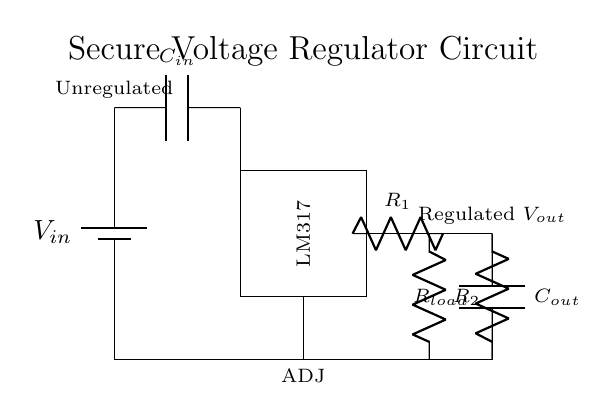What type of voltage regulator is shown? The circuit depicts a linear voltage regulator, specifically the LM317, which is designed to provide a stable output voltage.
Answer: LM317 What is the function of capacitor C_in? Capacitor C_in is used to filter and smooth out the input voltage to the regulator, reducing spikes and noise for stable operation.
Answer: Filter What is the output voltage labeled as in this circuit? The output voltage is labeled as V_out, indicating the regulated voltage supplied to the load connected at the output of the circuit.
Answer: V_out What components comprise the voltage divider in the circuit? The voltage divider consists of two resistors, R_1 and R_2, which set the output voltage based on their resistance values.
Answer: R_1, R_2 Why is there a need for the adjustment pin in the circuit? The ADJ pin allows for adjusting the output voltage level by connecting it to a voltage divider network, thus providing flexibility in output settings.
Answer: Flexibility What happens to the output when R_load increases significantly? When R_load increases, the load current decreases, potentially causing the output voltage to rise if the LM317 is not properly compensated, risking overvoltage on the load.
Answer: Overvoltage risk How does this circuit ensure suitable power for sensitive equipment? The LM317 voltage regulator maintains a stable output voltage despite variations in input voltage or load current, crucial for sensitive equipment that requires consistent voltage levels.
Answer: Stable voltage 